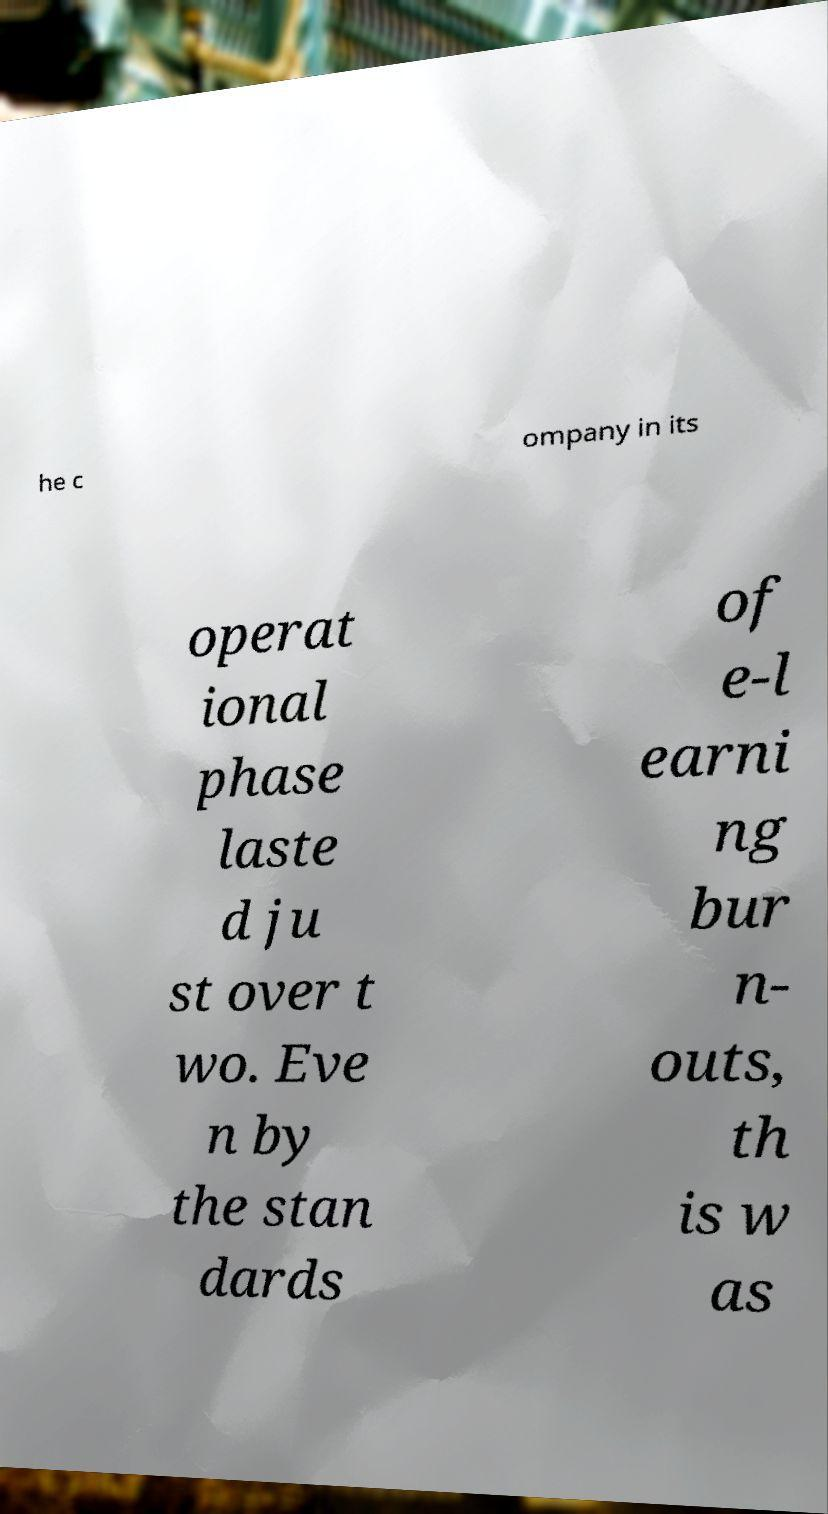Please read and relay the text visible in this image. What does it say? he c ompany in its operat ional phase laste d ju st over t wo. Eve n by the stan dards of e-l earni ng bur n- outs, th is w as 